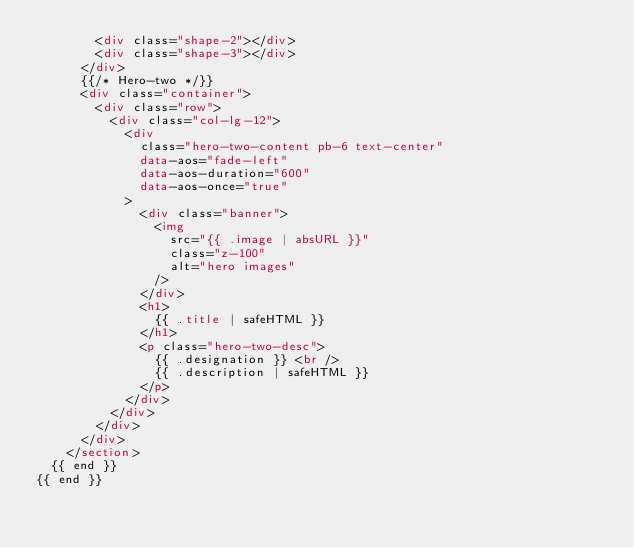<code> <loc_0><loc_0><loc_500><loc_500><_HTML_>        <div class="shape-2"></div>
        <div class="shape-3"></div>
      </div>
      {{/* Hero-two */}}
      <div class="container">
        <div class="row">
          <div class="col-lg-12">
            <div
              class="hero-two-content pb-6 text-center"
              data-aos="fade-left"
              data-aos-duration="600"
              data-aos-once="true"
            >
              <div class="banner">
                <img
                  src="{{ .image | absURL }}"
                  class="z-100"
                  alt="hero images"
                />
              </div>
              <h1>
                {{ .title | safeHTML }}
              </h1>
              <p class="hero-two-desc">
                {{ .designation }} <br />
                {{ .description | safeHTML }}
              </p>
            </div>
          </div>
        </div>
      </div>
    </section>
  {{ end }}
{{ end }}</code> 